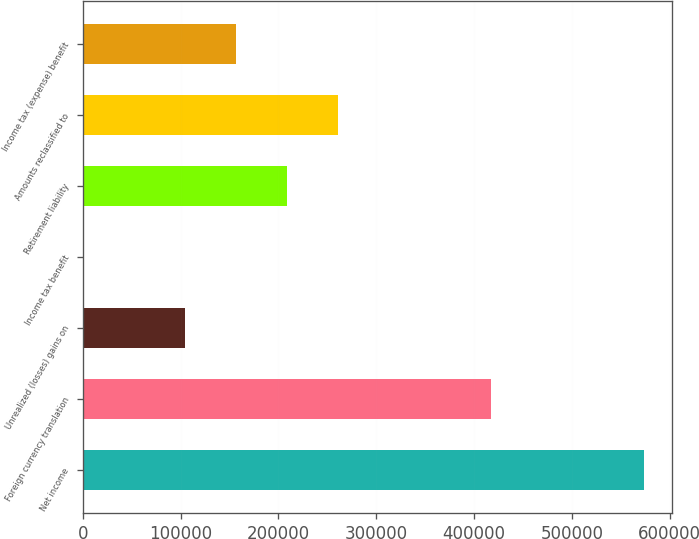Convert chart. <chart><loc_0><loc_0><loc_500><loc_500><bar_chart><fcel>Net income<fcel>Foreign currency translation<fcel>Unrealized (losses) gains on<fcel>Income tax benefit<fcel>Retirement liability<fcel>Amounts reclassified to<fcel>Income tax (expense) benefit<nl><fcel>573642<fcel>417225<fcel>104389<fcel>111<fcel>208668<fcel>260807<fcel>156529<nl></chart> 